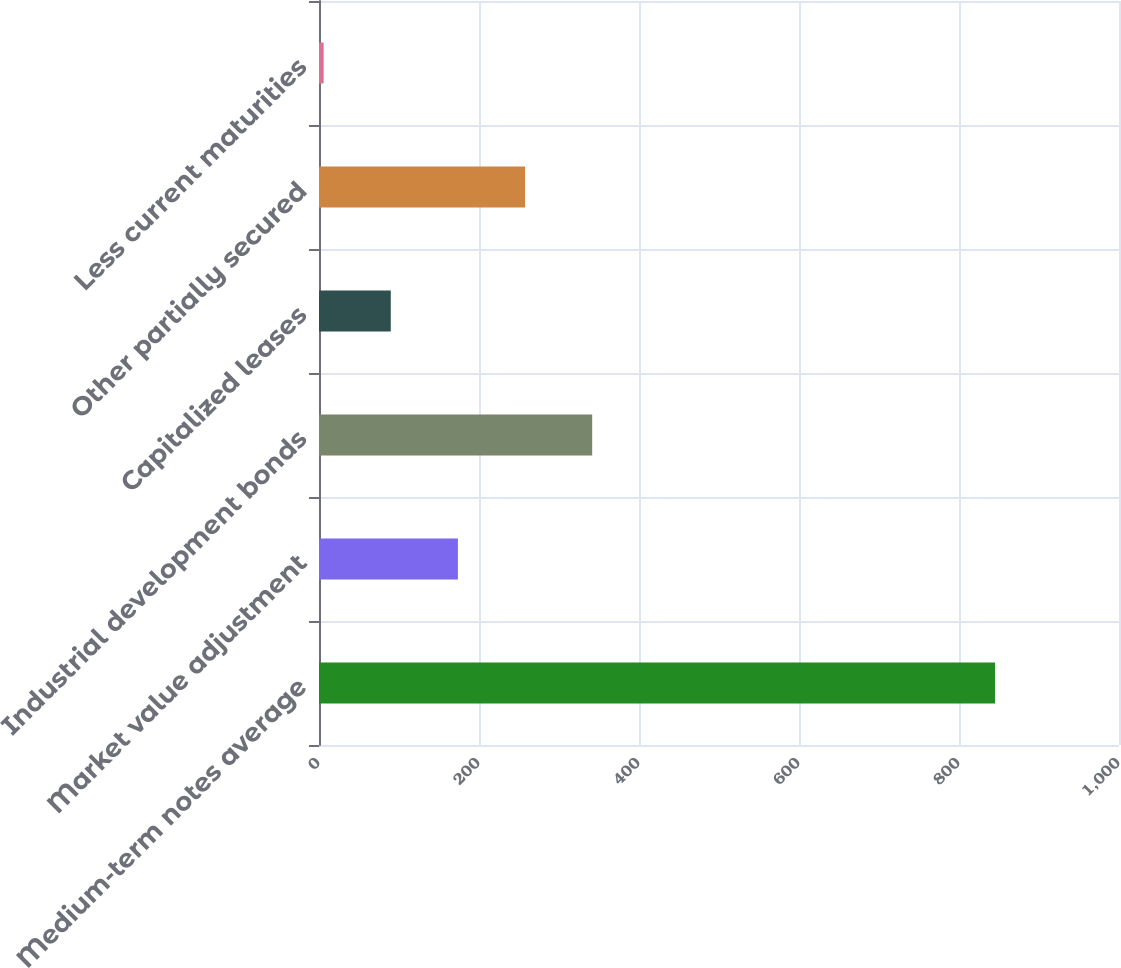<chart> <loc_0><loc_0><loc_500><loc_500><bar_chart><fcel>Medium-term notes average<fcel>Market value adjustment<fcel>Industrial development bonds<fcel>Capitalized leases<fcel>Other partially secured<fcel>Less current maturities<nl><fcel>845<fcel>173.64<fcel>341.48<fcel>89.72<fcel>257.56<fcel>5.8<nl></chart> 